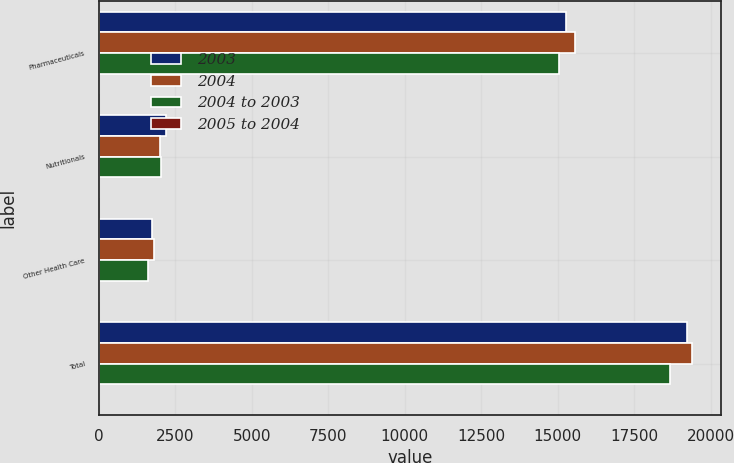Convert chart to OTSL. <chart><loc_0><loc_0><loc_500><loc_500><stacked_bar_chart><ecel><fcel>Pharmaceuticals<fcel>Nutritionals<fcel>Other Health Care<fcel>Total<nl><fcel>2003<fcel>15254<fcel>2205<fcel>1748<fcel>19207<nl><fcel>2004<fcel>15564<fcel>2001<fcel>1815<fcel>19380<nl><fcel>2004 to 2003<fcel>15025<fcel>2023<fcel>1605<fcel>18653<nl><fcel>2005 to 2004<fcel>2<fcel>10<fcel>4<fcel>1<nl></chart> 